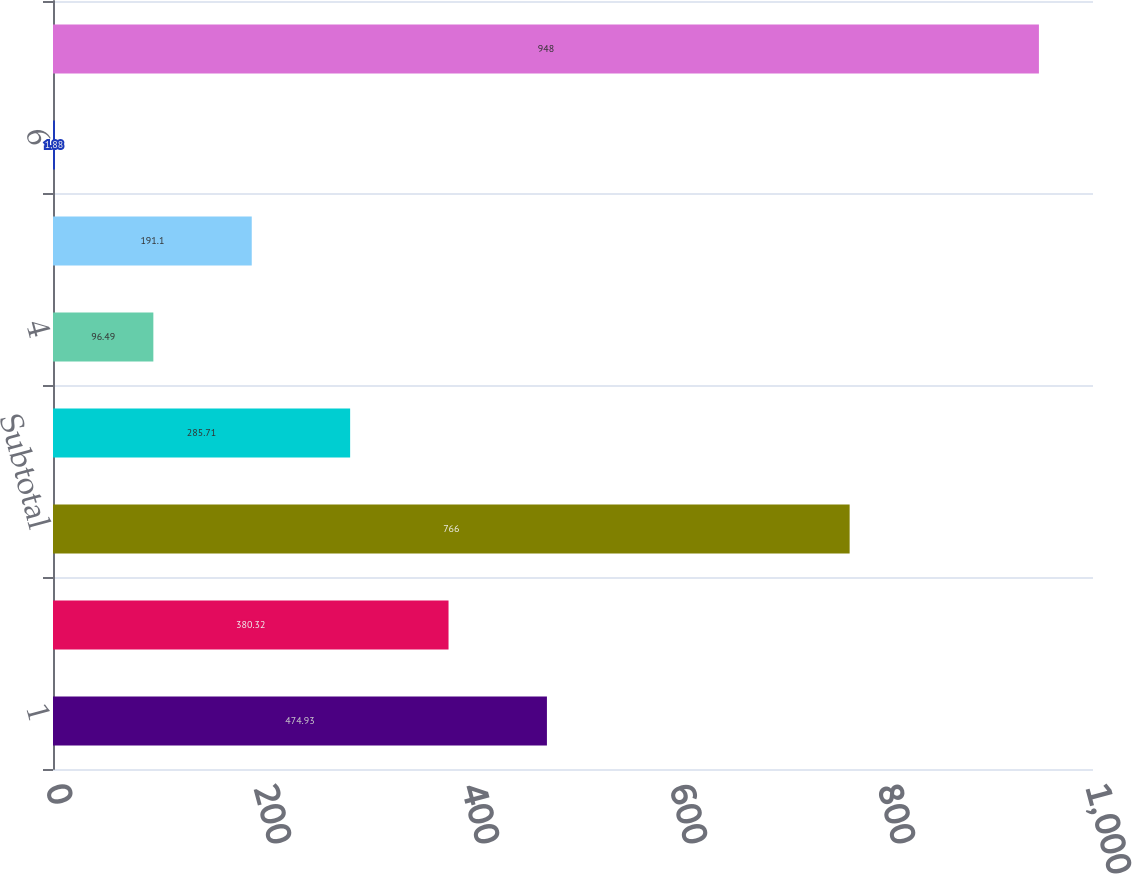Convert chart to OTSL. <chart><loc_0><loc_0><loc_500><loc_500><bar_chart><fcel>1<fcel>2<fcel>Subtotal<fcel>3<fcel>4<fcel>5<fcel>6<fcel>Total(2)<nl><fcel>474.93<fcel>380.32<fcel>766<fcel>285.71<fcel>96.49<fcel>191.1<fcel>1.88<fcel>948<nl></chart> 